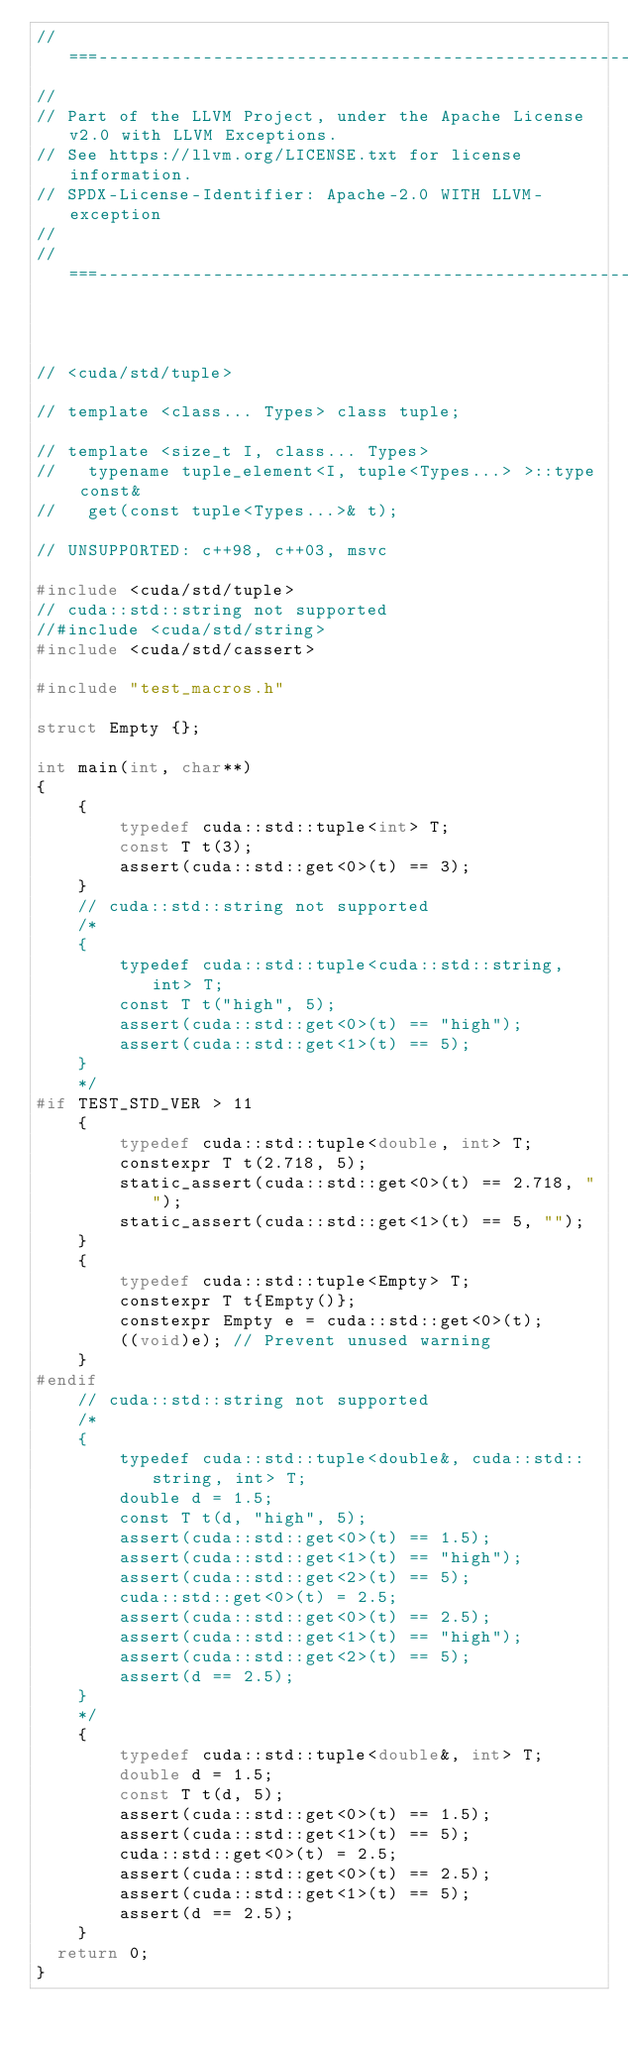<code> <loc_0><loc_0><loc_500><loc_500><_C++_>//===----------------------------------------------------------------------===//
//
// Part of the LLVM Project, under the Apache License v2.0 with LLVM Exceptions.
// See https://llvm.org/LICENSE.txt for license information.
// SPDX-License-Identifier: Apache-2.0 WITH LLVM-exception
//
//===----------------------------------------------------------------------===//



// <cuda/std/tuple>

// template <class... Types> class tuple;

// template <size_t I, class... Types>
//   typename tuple_element<I, tuple<Types...> >::type const&
//   get(const tuple<Types...>& t);

// UNSUPPORTED: c++98, c++03, msvc

#include <cuda/std/tuple>
// cuda::std::string not supported
//#include <cuda/std/string>
#include <cuda/std/cassert>

#include "test_macros.h"

struct Empty {};

int main(int, char**)
{
    {
        typedef cuda::std::tuple<int> T;
        const T t(3);
        assert(cuda::std::get<0>(t) == 3);
    }
    // cuda::std::string not supported
    /*
    {
        typedef cuda::std::tuple<cuda::std::string, int> T;
        const T t("high", 5);
        assert(cuda::std::get<0>(t) == "high");
        assert(cuda::std::get<1>(t) == 5);
    }
    */
#if TEST_STD_VER > 11
    {
        typedef cuda::std::tuple<double, int> T;
        constexpr T t(2.718, 5);
        static_assert(cuda::std::get<0>(t) == 2.718, "");
        static_assert(cuda::std::get<1>(t) == 5, "");
    }
    {
        typedef cuda::std::tuple<Empty> T;
        constexpr T t{Empty()};
        constexpr Empty e = cuda::std::get<0>(t);
        ((void)e); // Prevent unused warning
    }
#endif
    // cuda::std::string not supported
    /*
    {
        typedef cuda::std::tuple<double&, cuda::std::string, int> T;
        double d = 1.5;
        const T t(d, "high", 5);
        assert(cuda::std::get<0>(t) == 1.5);
        assert(cuda::std::get<1>(t) == "high");
        assert(cuda::std::get<2>(t) == 5);
        cuda::std::get<0>(t) = 2.5;
        assert(cuda::std::get<0>(t) == 2.5);
        assert(cuda::std::get<1>(t) == "high");
        assert(cuda::std::get<2>(t) == 5);
        assert(d == 2.5);
    }
    */
    {
        typedef cuda::std::tuple<double&, int> T;
        double d = 1.5;
        const T t(d, 5);
        assert(cuda::std::get<0>(t) == 1.5);
        assert(cuda::std::get<1>(t) == 5);
        cuda::std::get<0>(t) = 2.5;
        assert(cuda::std::get<0>(t) == 2.5);
        assert(cuda::std::get<1>(t) == 5);
        assert(d == 2.5);
    }
  return 0;
}
</code> 